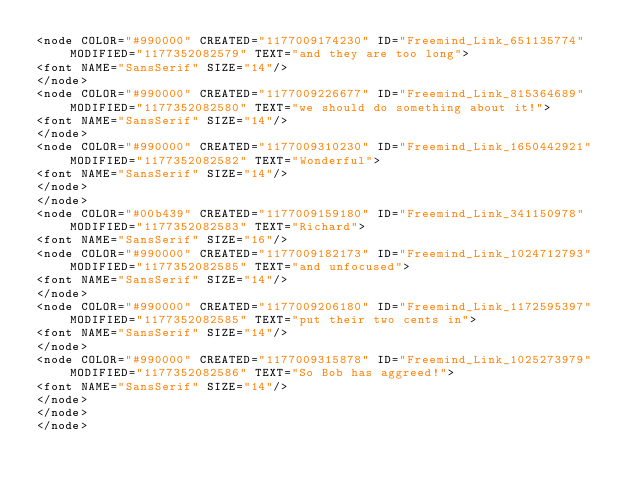<code> <loc_0><loc_0><loc_500><loc_500><_ObjectiveC_><node COLOR="#990000" CREATED="1177009174230" ID="Freemind_Link_651135774" MODIFIED="1177352082579" TEXT="and they are too long">
<font NAME="SansSerif" SIZE="14"/>
</node>
<node COLOR="#990000" CREATED="1177009226677" ID="Freemind_Link_815364689" MODIFIED="1177352082580" TEXT="we should do something about it!">
<font NAME="SansSerif" SIZE="14"/>
</node>
<node COLOR="#990000" CREATED="1177009310230" ID="Freemind_Link_1650442921" MODIFIED="1177352082582" TEXT="Wonderful">
<font NAME="SansSerif" SIZE="14"/>
</node>
</node>
<node COLOR="#00b439" CREATED="1177009159180" ID="Freemind_Link_341150978" MODIFIED="1177352082583" TEXT="Richard">
<font NAME="SansSerif" SIZE="16"/>
<node COLOR="#990000" CREATED="1177009182173" ID="Freemind_Link_1024712793" MODIFIED="1177352082585" TEXT="and unfocused">
<font NAME="SansSerif" SIZE="14"/>
</node>
<node COLOR="#990000" CREATED="1177009206180" ID="Freemind_Link_1172595397" MODIFIED="1177352082585" TEXT="put their two cents in">
<font NAME="SansSerif" SIZE="14"/>
</node>
<node COLOR="#990000" CREATED="1177009315878" ID="Freemind_Link_1025273979" MODIFIED="1177352082586" TEXT="So Bob has aggreed!">
<font NAME="SansSerif" SIZE="14"/>
</node>
</node>
</node></code> 